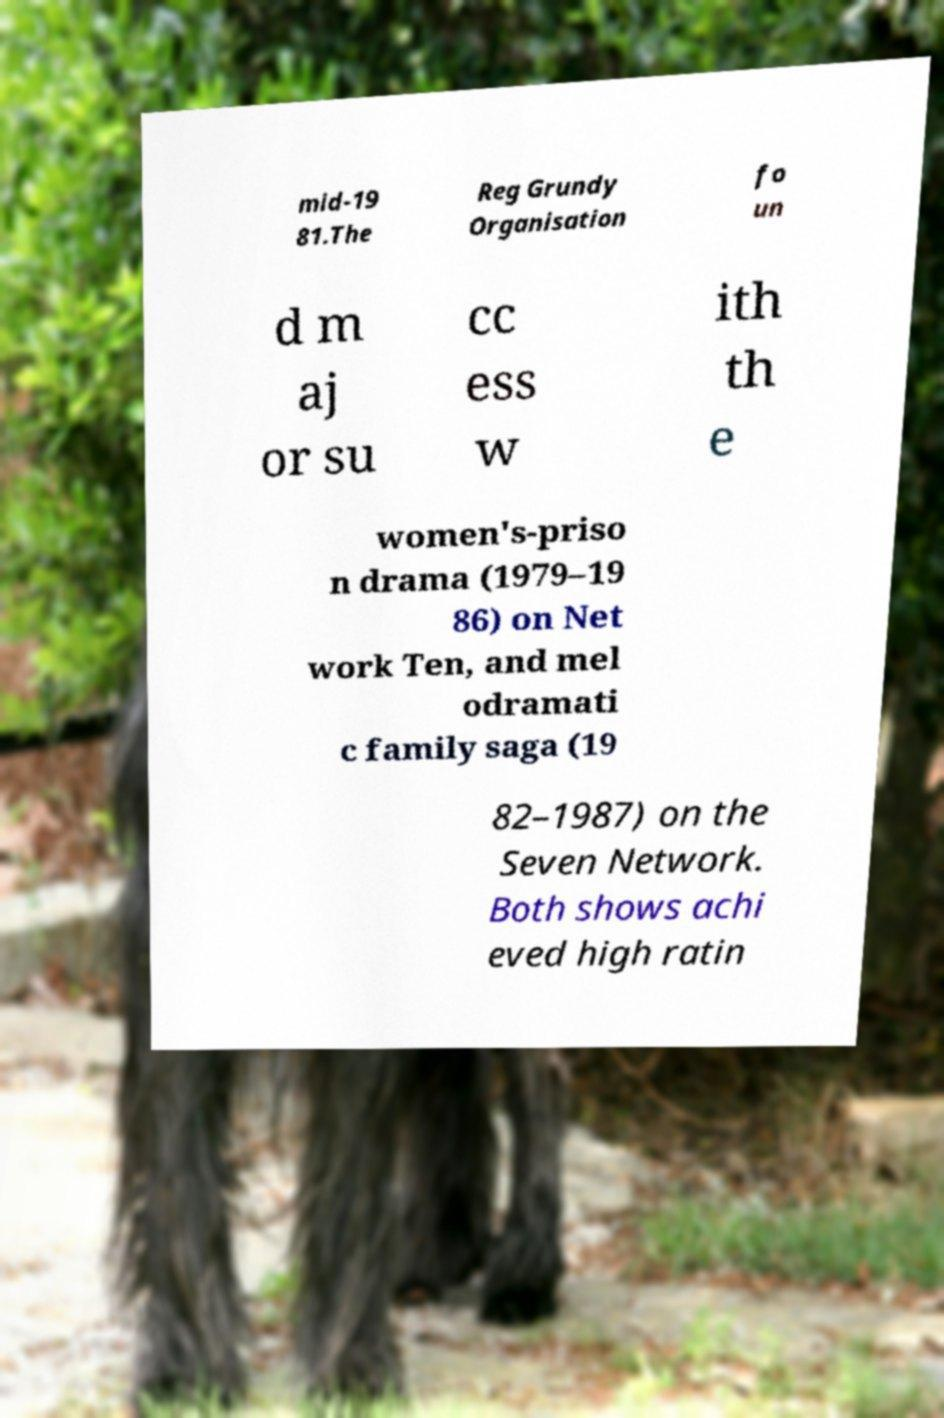I need the written content from this picture converted into text. Can you do that? mid-19 81.The Reg Grundy Organisation fo un d m aj or su cc ess w ith th e women's-priso n drama (1979–19 86) on Net work Ten, and mel odramati c family saga (19 82–1987) on the Seven Network. Both shows achi eved high ratin 